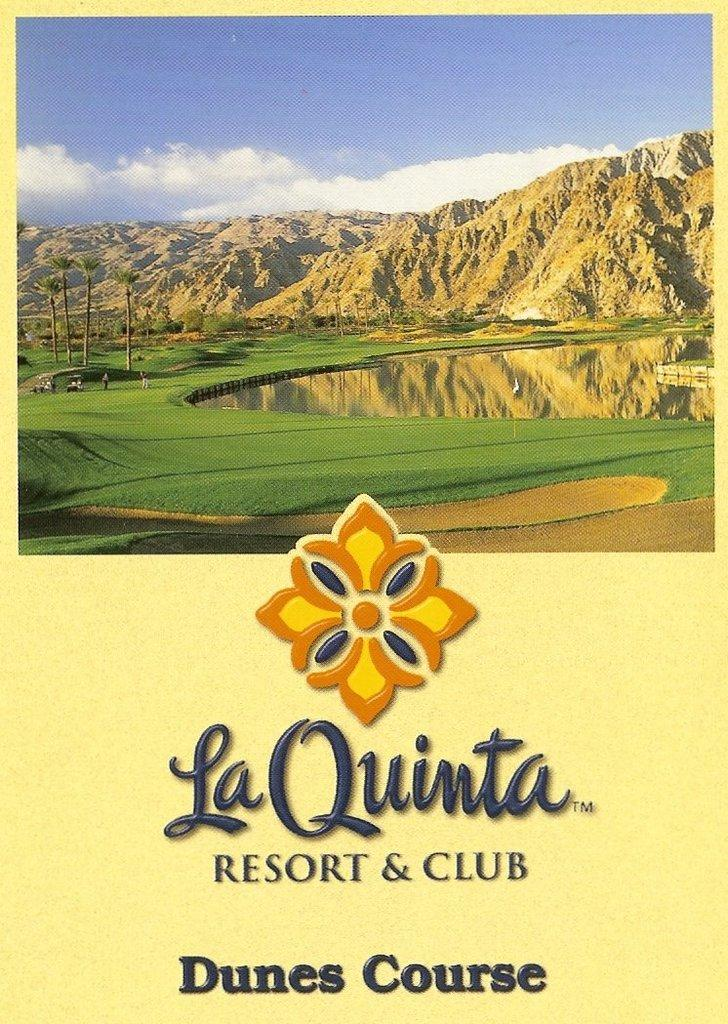What is the main subject of the card in the image? The card contains a depiction of mountains, water, trees, and a cloudy sky. What type of natural features are depicted on the card? The card depicts mountains, water, and trees. What is the condition of the sky in the image? The sky is depicted as cloudy on the card. Is there any text present on the card? Yes, there is text on the card. What type of metal pipe can be seen in the image? There is no metal pipe present in the image; the image features a card with a depiction of mountains, water, trees, and a cloudy sky. What is the amount of debt depicted on the card? There is no depiction of debt on the card; it features a landscape scene with mountains, water, trees, and a cloudy sky. 